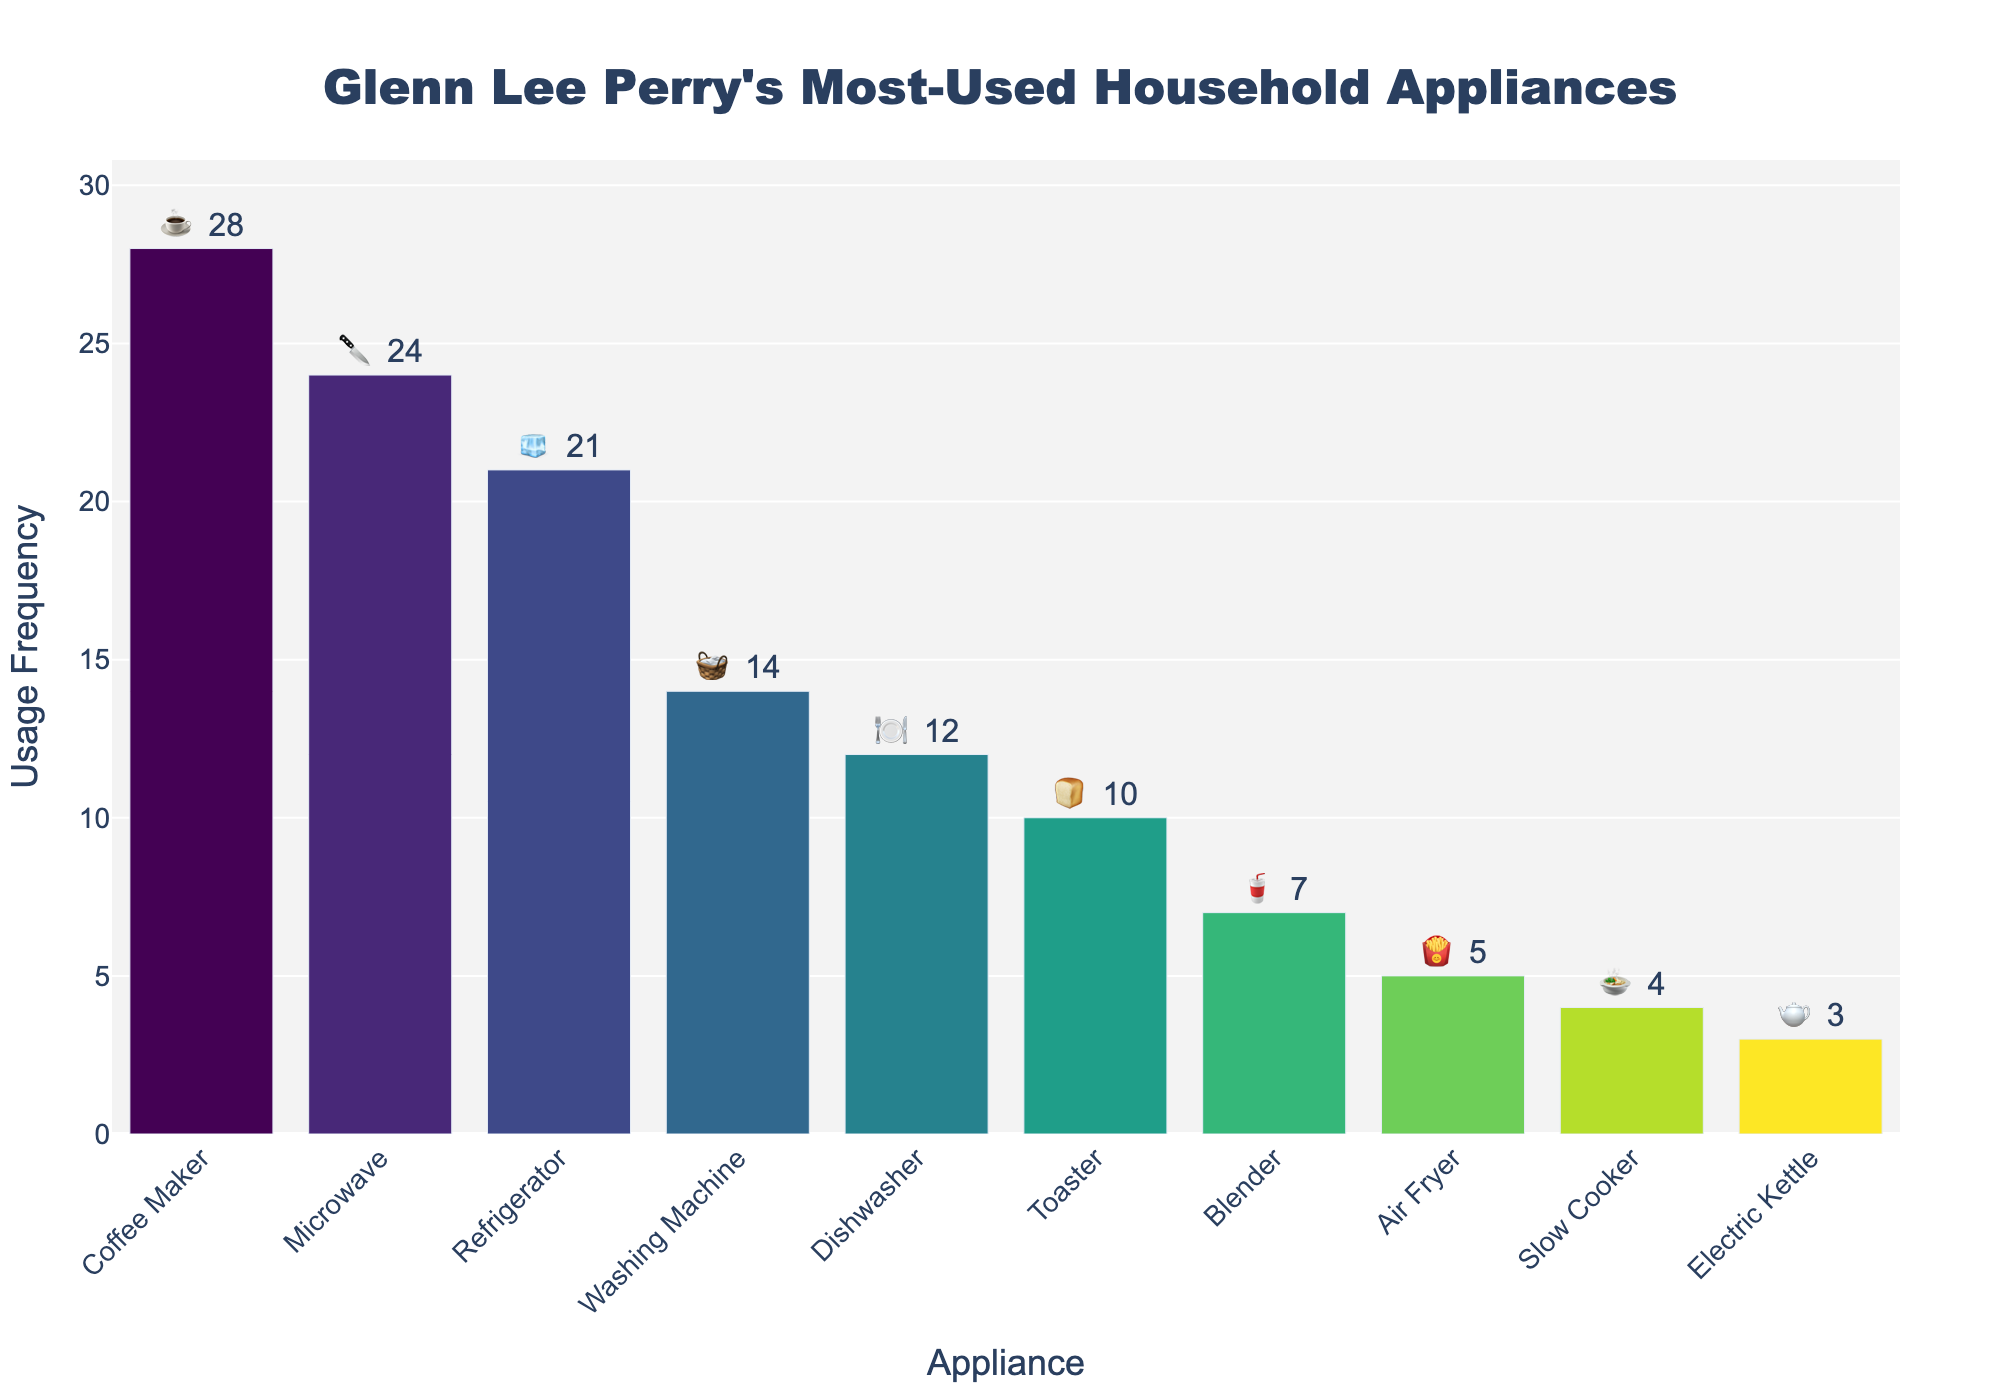Which appliance is used the most by Glenn Lee Perry? The tallest bar in the chart, labeled with the coffee maker emoji (☕), represents the Coffee Maker at a usage frequency of 28.
Answer: Coffee Maker What is the total usage frequency of all appliances combined? Summing the values for the usage frequencies (28 + 24 + 21 + 14 + 12 + 10 + 7 + 5 + 4 + 3) results in a total of 128.
Answer: 128 Which appliance is used more frequently, the Blender or the Toaster? The chart shows the Toaster with a frequency of 10 and the Blender with a frequency of 7. Comparing these, the Toaster has a higher frequency.
Answer: Toaster What is the difference in usage frequency between the Electric Kettle and the Microwave? The Microwave has a frequency of 24 and the Electric Kettle has a frequency of 3. Subtracting these gives 24 - 3 = 21.
Answer: 21 In terms of usage frequency, which appliance ranks just below the Refrigerator? The Refrigerator has a frequency of 21. The next appliance with the lower frequency is the Washing Machine, represented with 14.
Answer: Washing Machine What is the combined usage frequency of the Dishwasher and the Air Fryer? The Dishwasher has a frequency of 12 and the Air Fryer has a frequency of 5. Combining these gives 12 + 5 = 17.
Answer: 17 Among the listed appliances, which one has the lowest usage frequency? The shortest bar in the chart, labeled with the Electric Kettle emoji (🫖), represents the Electric Kettle with a usage frequency of 3.
Answer: Electric Kettle 